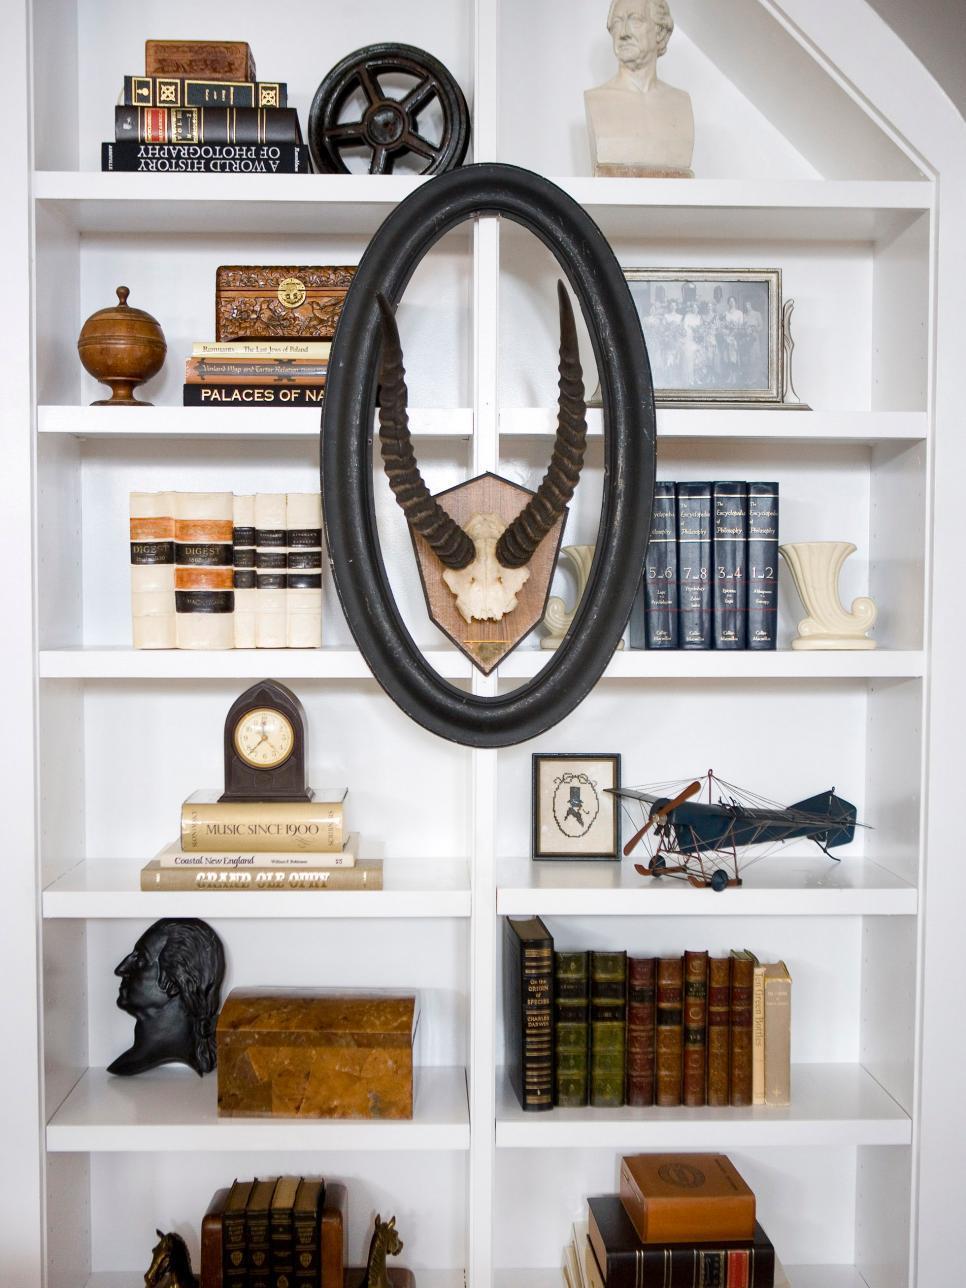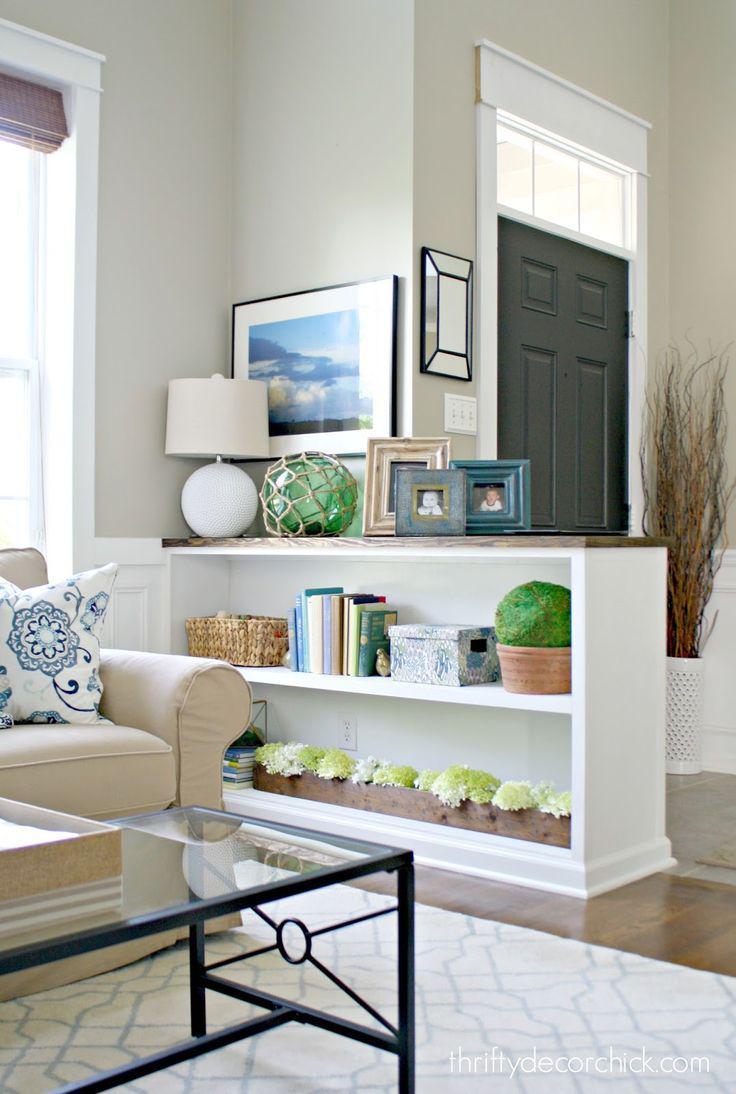The first image is the image on the left, the second image is the image on the right. Examine the images to the left and right. Is the description "In one image, artwork is hung on the center front of a white built-in shelving unit." accurate? Answer yes or no. Yes. The first image is the image on the left, the second image is the image on the right. Given the left and right images, does the statement "One image is a room with a chandelier and a white bookcase that fills a wall." hold true? Answer yes or no. No. 